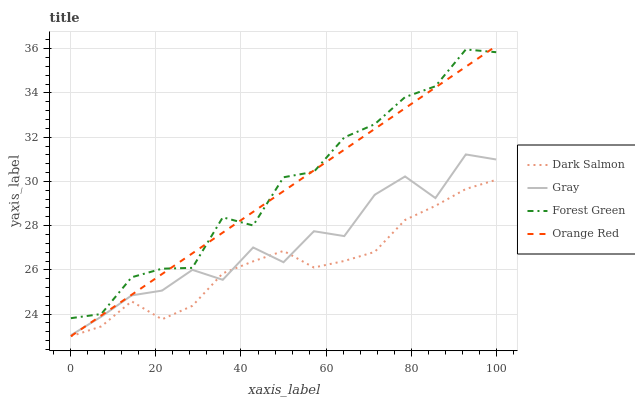Does Dark Salmon have the minimum area under the curve?
Answer yes or no. Yes. Does Forest Green have the maximum area under the curve?
Answer yes or no. Yes. Does Forest Green have the minimum area under the curve?
Answer yes or no. No. Does Dark Salmon have the maximum area under the curve?
Answer yes or no. No. Is Orange Red the smoothest?
Answer yes or no. Yes. Is Gray the roughest?
Answer yes or no. Yes. Is Forest Green the smoothest?
Answer yes or no. No. Is Forest Green the roughest?
Answer yes or no. No. Does Forest Green have the lowest value?
Answer yes or no. No. Does Forest Green have the highest value?
Answer yes or no. No. Is Dark Salmon less than Forest Green?
Answer yes or no. Yes. Is Forest Green greater than Dark Salmon?
Answer yes or no. Yes. Does Dark Salmon intersect Forest Green?
Answer yes or no. No. 